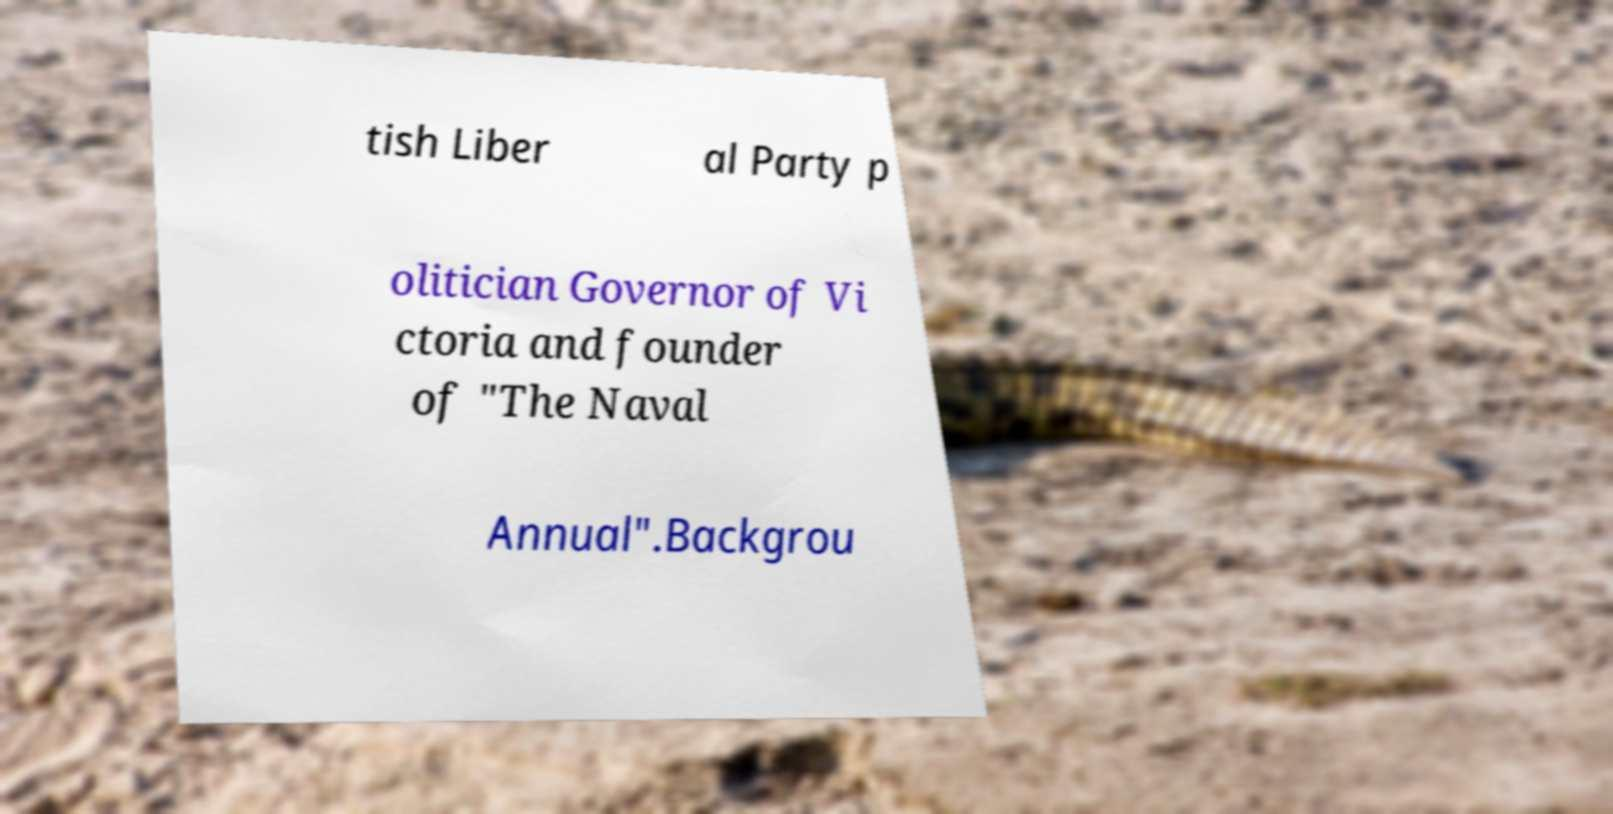I need the written content from this picture converted into text. Can you do that? tish Liber al Party p olitician Governor of Vi ctoria and founder of "The Naval Annual".Backgrou 